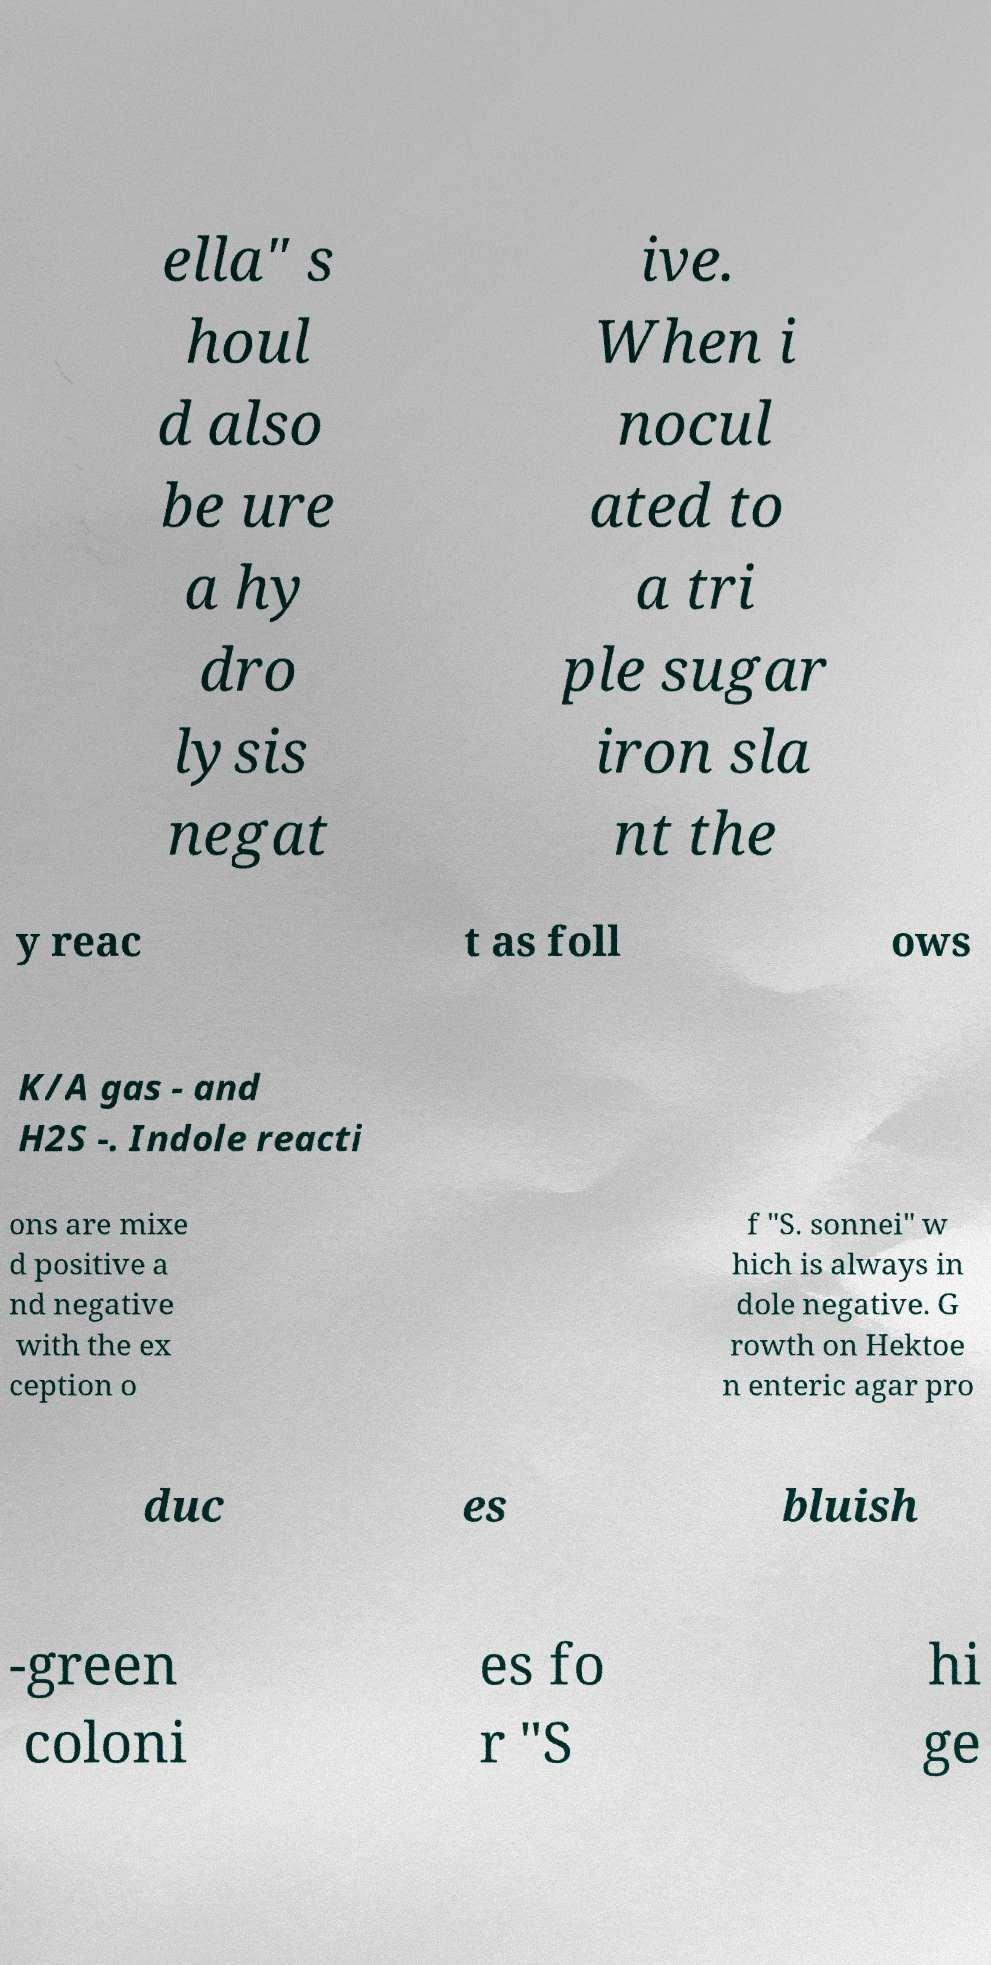Please read and relay the text visible in this image. What does it say? ella" s houl d also be ure a hy dro lysis negat ive. When i nocul ated to a tri ple sugar iron sla nt the y reac t as foll ows K/A gas - and H2S -. Indole reacti ons are mixe d positive a nd negative with the ex ception o f "S. sonnei" w hich is always in dole negative. G rowth on Hektoe n enteric agar pro duc es bluish -green coloni es fo r "S hi ge 